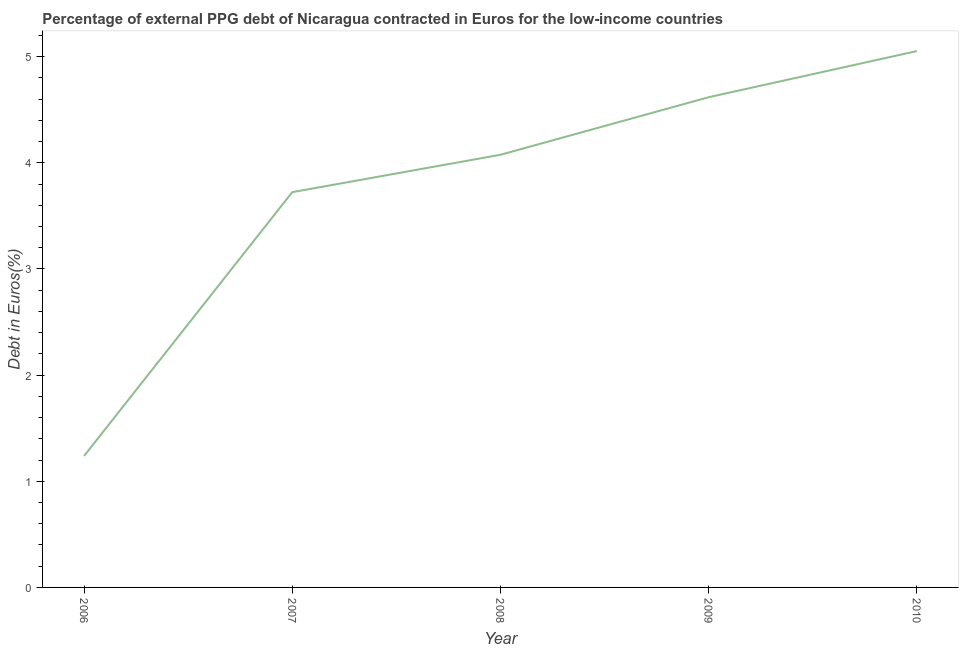What is the currency composition of ppg debt in 2009?
Provide a short and direct response. 4.62. Across all years, what is the maximum currency composition of ppg debt?
Give a very brief answer. 5.05. Across all years, what is the minimum currency composition of ppg debt?
Your answer should be compact. 1.24. In which year was the currency composition of ppg debt maximum?
Provide a succinct answer. 2010. What is the sum of the currency composition of ppg debt?
Your response must be concise. 18.71. What is the difference between the currency composition of ppg debt in 2006 and 2007?
Your answer should be compact. -2.49. What is the average currency composition of ppg debt per year?
Give a very brief answer. 3.74. What is the median currency composition of ppg debt?
Offer a terse response. 4.08. Do a majority of the years between 2009 and 2006 (inclusive) have currency composition of ppg debt greater than 1.2 %?
Your answer should be very brief. Yes. What is the ratio of the currency composition of ppg debt in 2006 to that in 2009?
Ensure brevity in your answer.  0.27. What is the difference between the highest and the second highest currency composition of ppg debt?
Give a very brief answer. 0.43. Is the sum of the currency composition of ppg debt in 2009 and 2010 greater than the maximum currency composition of ppg debt across all years?
Keep it short and to the point. Yes. What is the difference between the highest and the lowest currency composition of ppg debt?
Give a very brief answer. 3.81. Does the currency composition of ppg debt monotonically increase over the years?
Your answer should be compact. Yes. Does the graph contain grids?
Provide a short and direct response. No. What is the title of the graph?
Offer a very short reply. Percentage of external PPG debt of Nicaragua contracted in Euros for the low-income countries. What is the label or title of the X-axis?
Offer a very short reply. Year. What is the label or title of the Y-axis?
Offer a very short reply. Debt in Euros(%). What is the Debt in Euros(%) of 2006?
Offer a terse response. 1.24. What is the Debt in Euros(%) in 2007?
Your answer should be compact. 3.72. What is the Debt in Euros(%) in 2008?
Keep it short and to the point. 4.08. What is the Debt in Euros(%) of 2009?
Offer a very short reply. 4.62. What is the Debt in Euros(%) in 2010?
Your response must be concise. 5.05. What is the difference between the Debt in Euros(%) in 2006 and 2007?
Provide a succinct answer. -2.49. What is the difference between the Debt in Euros(%) in 2006 and 2008?
Give a very brief answer. -2.84. What is the difference between the Debt in Euros(%) in 2006 and 2009?
Offer a very short reply. -3.38. What is the difference between the Debt in Euros(%) in 2006 and 2010?
Your answer should be compact. -3.81. What is the difference between the Debt in Euros(%) in 2007 and 2008?
Ensure brevity in your answer.  -0.35. What is the difference between the Debt in Euros(%) in 2007 and 2009?
Give a very brief answer. -0.89. What is the difference between the Debt in Euros(%) in 2007 and 2010?
Your response must be concise. -1.33. What is the difference between the Debt in Euros(%) in 2008 and 2009?
Your response must be concise. -0.54. What is the difference between the Debt in Euros(%) in 2008 and 2010?
Provide a short and direct response. -0.98. What is the difference between the Debt in Euros(%) in 2009 and 2010?
Your answer should be very brief. -0.43. What is the ratio of the Debt in Euros(%) in 2006 to that in 2007?
Your answer should be compact. 0.33. What is the ratio of the Debt in Euros(%) in 2006 to that in 2008?
Offer a very short reply. 0.3. What is the ratio of the Debt in Euros(%) in 2006 to that in 2009?
Provide a short and direct response. 0.27. What is the ratio of the Debt in Euros(%) in 2006 to that in 2010?
Offer a terse response. 0.24. What is the ratio of the Debt in Euros(%) in 2007 to that in 2008?
Provide a short and direct response. 0.91. What is the ratio of the Debt in Euros(%) in 2007 to that in 2009?
Offer a terse response. 0.81. What is the ratio of the Debt in Euros(%) in 2007 to that in 2010?
Provide a succinct answer. 0.74. What is the ratio of the Debt in Euros(%) in 2008 to that in 2009?
Offer a terse response. 0.88. What is the ratio of the Debt in Euros(%) in 2008 to that in 2010?
Your answer should be very brief. 0.81. What is the ratio of the Debt in Euros(%) in 2009 to that in 2010?
Ensure brevity in your answer.  0.91. 